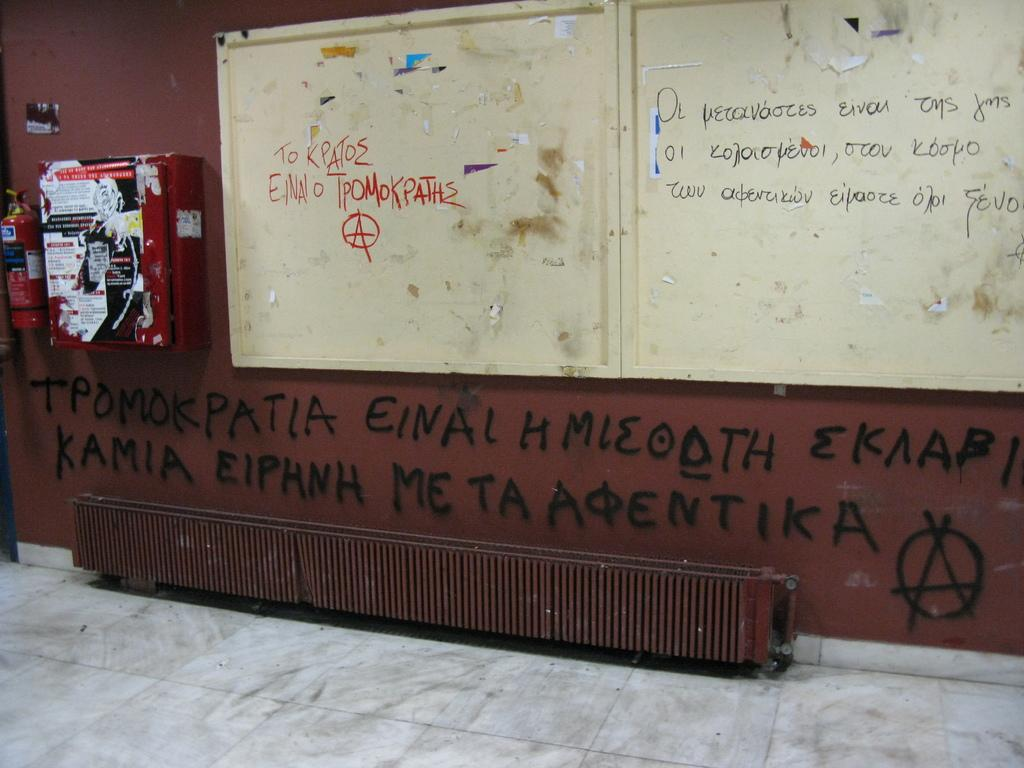Provide a one-sentence caption for the provided image. A wall covered in graffiti some of which says KAMIA EIPHNH. 